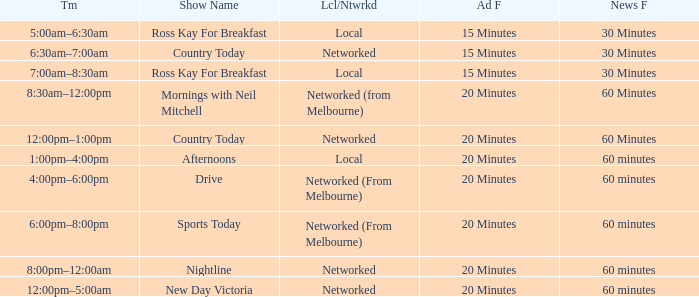What News Freq has a Time of 1:00pm–4:00pm? 60 minutes. 